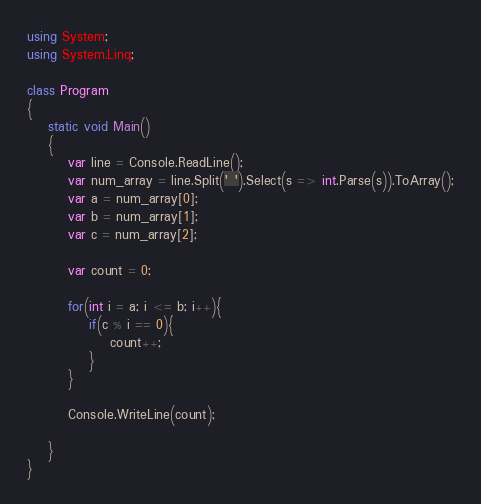<code> <loc_0><loc_0><loc_500><loc_500><_C#_>using System;
using System.Linq;

class Program
{
    static void Main()
    {
        var line = Console.ReadLine();
        var num_array = line.Split(' ').Select(s => int.Parse(s)).ToArray();
        var a = num_array[0];
        var b = num_array[1];
        var c = num_array[2];
        
        var count = 0;
        
        for(int i = a; i <= b; i++){
            if(c % i == 0){
                count++;
            }
        }
        
        Console.WriteLine(count);
        
    }
}

</code> 